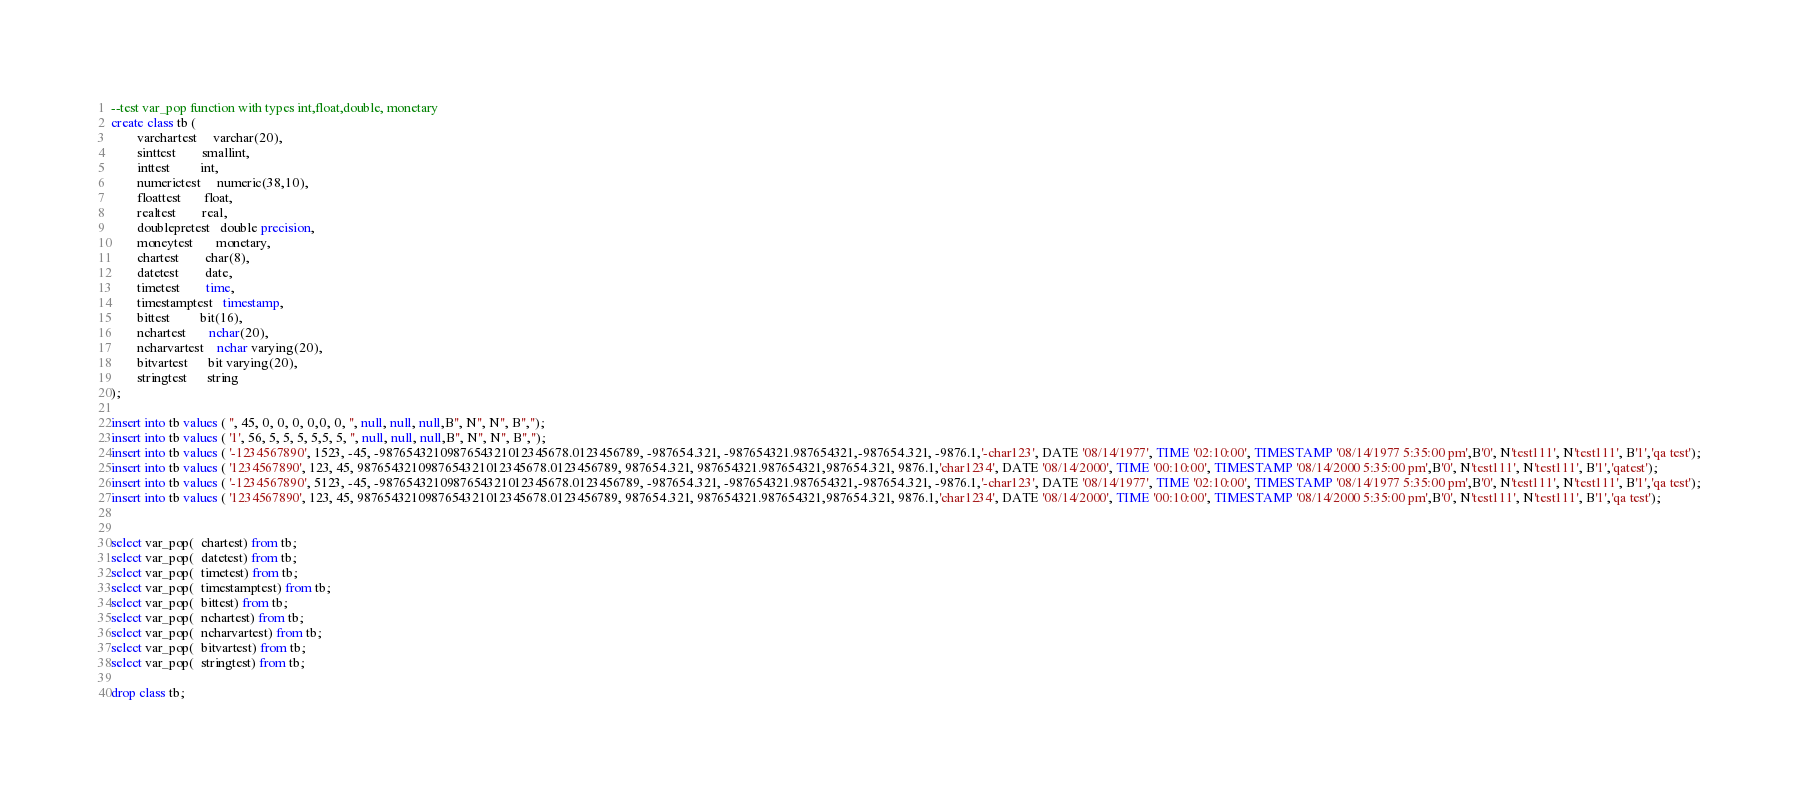Convert code to text. <code><loc_0><loc_0><loc_500><loc_500><_SQL_>--test var_pop function with types int,float,double, monetary 
create class tb (
		varchartest     varchar(20),
		sinttest        smallint,
		inttest         int,
		numerictest     numeric(38,10),
		floattest       float,
		realtest        real,
		doublepretest   double precision,
		moneytest       monetary,
		chartest        char(8),
		datetest        date,
		timetest        time,
		timestamptest   timestamp,
		bittest         bit(16),
		nchartest       nchar(20),
		ncharvartest    nchar varying(20),
		bitvartest      bit varying(20),
		stringtest      string
);

insert into tb values ( '', 45, 0, 0, 0, 0,0, 0, '', null, null, null,B'', N'', N'', B'','');
insert into tb values ( '1', 56, 5, 5, 5, 5,5, 5, '', null, null, null,B'', N'', N'', B'','');
insert into tb values ( '-1234567890', 1523, -45, -9876543210987654321012345678.0123456789, -987654.321, -987654321.987654321,-987654.321, -9876.1,'-char123', DATE '08/14/1977', TIME '02:10:00', TIMESTAMP '08/14/1977 5:35:00 pm',B'0', N'test111', N'test111', B'1','qa test');
insert into tb values ( '1234567890', 123, 45, 9876543210987654321012345678.0123456789, 987654.321, 987654321.987654321,987654.321, 9876.1,'char1234', DATE '08/14/2000', TIME '00:10:00', TIMESTAMP '08/14/2000 5:35:00 pm',B'0', N'test111', N'test111', B'1','qatest');
insert into tb values ( '-1234567890', 5123, -45, -9876543210987654321012345678.0123456789, -987654.321, -987654321.987654321,-987654.321, -9876.1,'-char123', DATE '08/14/1977', TIME '02:10:00', TIMESTAMP '08/14/1977 5:35:00 pm',B'0', N'test111', N'test111', B'1','qa test');
insert into tb values ( '1234567890', 123, 45, 9876543210987654321012345678.0123456789, 987654.321, 987654321.987654321,987654.321, 9876.1,'char1234', DATE '08/14/2000', TIME '00:10:00', TIMESTAMP '08/14/2000 5:35:00 pm',B'0', N'test111', N'test111', B'1','qa test');


select var_pop(  chartest) from tb;
select var_pop(  datetest) from tb;
select var_pop(  timetest) from tb;
select var_pop(  timestamptest) from tb;
select var_pop(  bittest) from tb;
select var_pop(  nchartest) from tb;
select var_pop(  ncharvartest) from tb;
select var_pop(  bitvartest) from tb;
select var_pop(  stringtest) from tb;

drop class tb;
</code> 